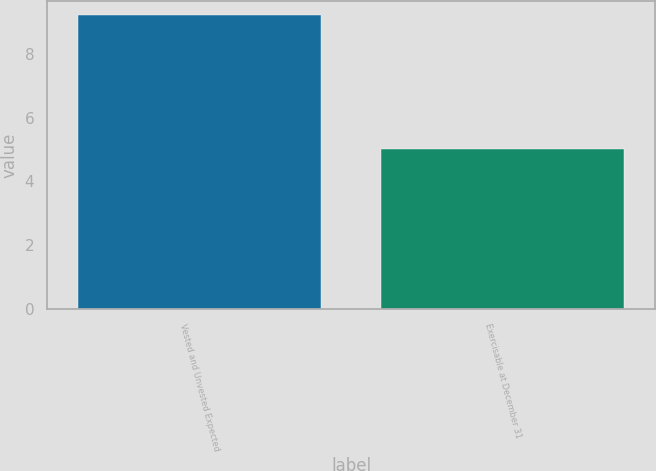<chart> <loc_0><loc_0><loc_500><loc_500><bar_chart><fcel>Vested and Unvested Expected<fcel>Exercisable at December 31<nl><fcel>9.2<fcel>5<nl></chart> 